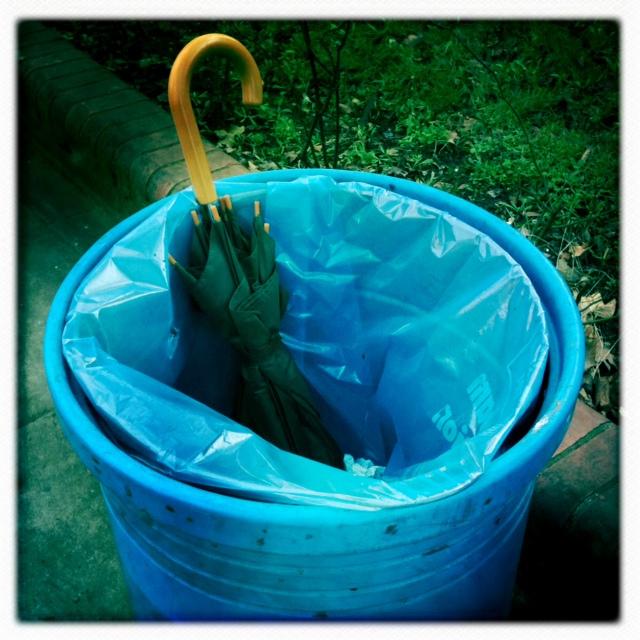What is the border in the background made of?
Quick response, please. Brick. Why is the umbrella in a garbage can?
Be succinct. Broken. What color is the trash bag?
Be succinct. Blue. 